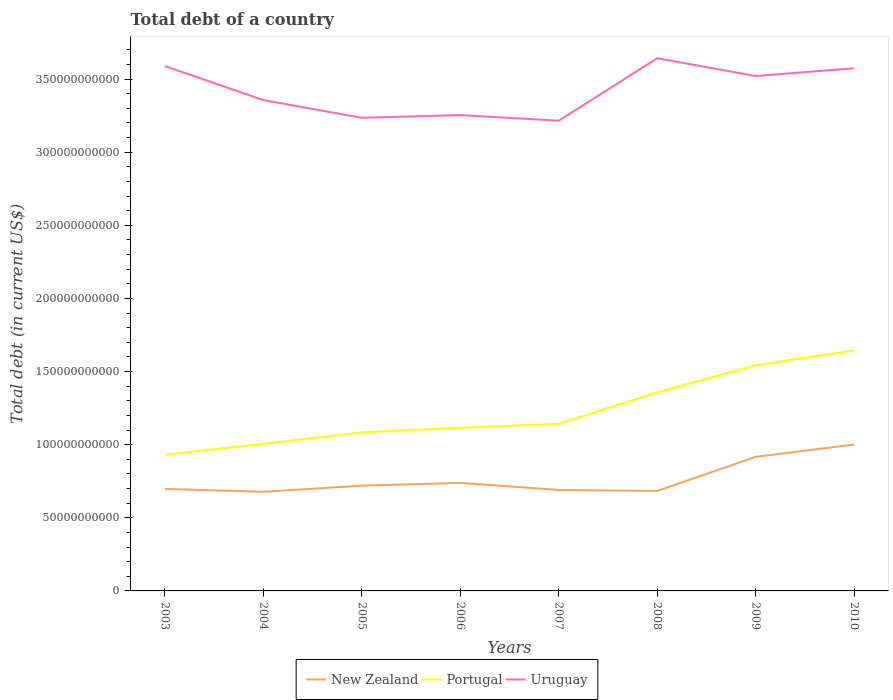How many different coloured lines are there?
Your answer should be compact. 3. Across all years, what is the maximum debt in Portugal?
Give a very brief answer. 9.32e+1. In which year was the debt in New Zealand maximum?
Your response must be concise. 2004. What is the total debt in Uruguay in the graph?
Offer a terse response. -1.85e+09. What is the difference between the highest and the second highest debt in New Zealand?
Your response must be concise. 3.23e+1. What is the difference between the highest and the lowest debt in New Zealand?
Keep it short and to the point. 2. Is the debt in New Zealand strictly greater than the debt in Portugal over the years?
Provide a succinct answer. Yes. How many lines are there?
Make the answer very short. 3. What is the difference between two consecutive major ticks on the Y-axis?
Ensure brevity in your answer.  5.00e+1. Does the graph contain any zero values?
Give a very brief answer. No. Where does the legend appear in the graph?
Your answer should be very brief. Bottom center. How many legend labels are there?
Ensure brevity in your answer.  3. How are the legend labels stacked?
Your answer should be compact. Horizontal. What is the title of the graph?
Offer a very short reply. Total debt of a country. Does "Uruguay" appear as one of the legend labels in the graph?
Offer a very short reply. Yes. What is the label or title of the Y-axis?
Give a very brief answer. Total debt (in current US$). What is the Total debt (in current US$) of New Zealand in 2003?
Offer a very short reply. 6.97e+1. What is the Total debt (in current US$) of Portugal in 2003?
Make the answer very short. 9.32e+1. What is the Total debt (in current US$) in Uruguay in 2003?
Your response must be concise. 3.59e+11. What is the Total debt (in current US$) in New Zealand in 2004?
Offer a very short reply. 6.78e+1. What is the Total debt (in current US$) in Portugal in 2004?
Your answer should be compact. 1.01e+11. What is the Total debt (in current US$) in Uruguay in 2004?
Provide a succinct answer. 3.36e+11. What is the Total debt (in current US$) of New Zealand in 2005?
Offer a terse response. 7.20e+1. What is the Total debt (in current US$) of Portugal in 2005?
Keep it short and to the point. 1.08e+11. What is the Total debt (in current US$) of Uruguay in 2005?
Give a very brief answer. 3.24e+11. What is the Total debt (in current US$) in New Zealand in 2006?
Offer a terse response. 7.39e+1. What is the Total debt (in current US$) in Portugal in 2006?
Keep it short and to the point. 1.12e+11. What is the Total debt (in current US$) of Uruguay in 2006?
Make the answer very short. 3.25e+11. What is the Total debt (in current US$) of New Zealand in 2007?
Make the answer very short. 6.90e+1. What is the Total debt (in current US$) of Portugal in 2007?
Provide a succinct answer. 1.14e+11. What is the Total debt (in current US$) in Uruguay in 2007?
Give a very brief answer. 3.22e+11. What is the Total debt (in current US$) of New Zealand in 2008?
Give a very brief answer. 6.84e+1. What is the Total debt (in current US$) in Portugal in 2008?
Make the answer very short. 1.36e+11. What is the Total debt (in current US$) of Uruguay in 2008?
Offer a terse response. 3.64e+11. What is the Total debt (in current US$) of New Zealand in 2009?
Your response must be concise. 9.17e+1. What is the Total debt (in current US$) in Portugal in 2009?
Offer a terse response. 1.54e+11. What is the Total debt (in current US$) in Uruguay in 2009?
Ensure brevity in your answer.  3.52e+11. What is the Total debt (in current US$) of New Zealand in 2010?
Offer a very short reply. 1.00e+11. What is the Total debt (in current US$) of Portugal in 2010?
Provide a succinct answer. 1.64e+11. What is the Total debt (in current US$) in Uruguay in 2010?
Your answer should be very brief. 3.57e+11. Across all years, what is the maximum Total debt (in current US$) in New Zealand?
Keep it short and to the point. 1.00e+11. Across all years, what is the maximum Total debt (in current US$) of Portugal?
Provide a succinct answer. 1.64e+11. Across all years, what is the maximum Total debt (in current US$) in Uruguay?
Your answer should be compact. 3.64e+11. Across all years, what is the minimum Total debt (in current US$) of New Zealand?
Keep it short and to the point. 6.78e+1. Across all years, what is the minimum Total debt (in current US$) in Portugal?
Offer a terse response. 9.32e+1. Across all years, what is the minimum Total debt (in current US$) of Uruguay?
Give a very brief answer. 3.22e+11. What is the total Total debt (in current US$) of New Zealand in the graph?
Ensure brevity in your answer.  6.13e+11. What is the total Total debt (in current US$) in Portugal in the graph?
Give a very brief answer. 9.83e+11. What is the total Total debt (in current US$) in Uruguay in the graph?
Your answer should be compact. 2.74e+12. What is the difference between the Total debt (in current US$) in New Zealand in 2003 and that in 2004?
Ensure brevity in your answer.  1.91e+09. What is the difference between the Total debt (in current US$) in Portugal in 2003 and that in 2004?
Make the answer very short. -7.46e+09. What is the difference between the Total debt (in current US$) in Uruguay in 2003 and that in 2004?
Offer a very short reply. 2.32e+1. What is the difference between the Total debt (in current US$) in New Zealand in 2003 and that in 2005?
Offer a terse response. -2.25e+09. What is the difference between the Total debt (in current US$) of Portugal in 2003 and that in 2005?
Give a very brief answer. -1.53e+1. What is the difference between the Total debt (in current US$) in Uruguay in 2003 and that in 2005?
Provide a succinct answer. 3.53e+1. What is the difference between the Total debt (in current US$) in New Zealand in 2003 and that in 2006?
Keep it short and to the point. -4.16e+09. What is the difference between the Total debt (in current US$) in Portugal in 2003 and that in 2006?
Your response must be concise. -1.84e+1. What is the difference between the Total debt (in current US$) of Uruguay in 2003 and that in 2006?
Your answer should be compact. 3.35e+1. What is the difference between the Total debt (in current US$) of New Zealand in 2003 and that in 2007?
Provide a short and direct response. 6.92e+08. What is the difference between the Total debt (in current US$) of Portugal in 2003 and that in 2007?
Offer a very short reply. -2.11e+1. What is the difference between the Total debt (in current US$) in Uruguay in 2003 and that in 2007?
Offer a very short reply. 3.73e+1. What is the difference between the Total debt (in current US$) in New Zealand in 2003 and that in 2008?
Make the answer very short. 1.35e+09. What is the difference between the Total debt (in current US$) of Portugal in 2003 and that in 2008?
Provide a succinct answer. -4.26e+1. What is the difference between the Total debt (in current US$) of Uruguay in 2003 and that in 2008?
Offer a terse response. -5.38e+09. What is the difference between the Total debt (in current US$) in New Zealand in 2003 and that in 2009?
Your answer should be very brief. -2.19e+1. What is the difference between the Total debt (in current US$) of Portugal in 2003 and that in 2009?
Offer a very short reply. -6.11e+1. What is the difference between the Total debt (in current US$) in Uruguay in 2003 and that in 2009?
Give a very brief answer. 6.76e+09. What is the difference between the Total debt (in current US$) of New Zealand in 2003 and that in 2010?
Give a very brief answer. -3.04e+1. What is the difference between the Total debt (in current US$) of Portugal in 2003 and that in 2010?
Your answer should be compact. -7.13e+1. What is the difference between the Total debt (in current US$) in Uruguay in 2003 and that in 2010?
Offer a terse response. 1.48e+09. What is the difference between the Total debt (in current US$) in New Zealand in 2004 and that in 2005?
Your response must be concise. -4.17e+09. What is the difference between the Total debt (in current US$) in Portugal in 2004 and that in 2005?
Make the answer very short. -7.86e+09. What is the difference between the Total debt (in current US$) of Uruguay in 2004 and that in 2005?
Give a very brief answer. 1.21e+1. What is the difference between the Total debt (in current US$) in New Zealand in 2004 and that in 2006?
Give a very brief answer. -6.08e+09. What is the difference between the Total debt (in current US$) of Portugal in 2004 and that in 2006?
Offer a terse response. -1.09e+1. What is the difference between the Total debt (in current US$) in Uruguay in 2004 and that in 2006?
Give a very brief answer. 1.02e+1. What is the difference between the Total debt (in current US$) of New Zealand in 2004 and that in 2007?
Your response must be concise. -1.22e+09. What is the difference between the Total debt (in current US$) of Portugal in 2004 and that in 2007?
Offer a very short reply. -1.37e+1. What is the difference between the Total debt (in current US$) of Uruguay in 2004 and that in 2007?
Offer a terse response. 1.41e+1. What is the difference between the Total debt (in current US$) of New Zealand in 2004 and that in 2008?
Make the answer very short. -5.67e+08. What is the difference between the Total debt (in current US$) in Portugal in 2004 and that in 2008?
Provide a short and direct response. -3.51e+1. What is the difference between the Total debt (in current US$) of Uruguay in 2004 and that in 2008?
Your answer should be very brief. -2.86e+1. What is the difference between the Total debt (in current US$) of New Zealand in 2004 and that in 2009?
Keep it short and to the point. -2.39e+1. What is the difference between the Total debt (in current US$) in Portugal in 2004 and that in 2009?
Ensure brevity in your answer.  -5.36e+1. What is the difference between the Total debt (in current US$) in Uruguay in 2004 and that in 2009?
Make the answer very short. -1.65e+1. What is the difference between the Total debt (in current US$) in New Zealand in 2004 and that in 2010?
Provide a short and direct response. -3.23e+1. What is the difference between the Total debt (in current US$) of Portugal in 2004 and that in 2010?
Keep it short and to the point. -6.39e+1. What is the difference between the Total debt (in current US$) of Uruguay in 2004 and that in 2010?
Provide a short and direct response. -2.18e+1. What is the difference between the Total debt (in current US$) in New Zealand in 2005 and that in 2006?
Ensure brevity in your answer.  -1.91e+09. What is the difference between the Total debt (in current US$) in Portugal in 2005 and that in 2006?
Provide a short and direct response. -3.09e+09. What is the difference between the Total debt (in current US$) of Uruguay in 2005 and that in 2006?
Provide a short and direct response. -1.85e+09. What is the difference between the Total debt (in current US$) in New Zealand in 2005 and that in 2007?
Offer a terse response. 2.95e+09. What is the difference between the Total debt (in current US$) of Portugal in 2005 and that in 2007?
Ensure brevity in your answer.  -5.83e+09. What is the difference between the Total debt (in current US$) of Uruguay in 2005 and that in 2007?
Make the answer very short. 1.99e+09. What is the difference between the Total debt (in current US$) of New Zealand in 2005 and that in 2008?
Offer a very short reply. 3.60e+09. What is the difference between the Total debt (in current US$) in Portugal in 2005 and that in 2008?
Keep it short and to the point. -2.73e+1. What is the difference between the Total debt (in current US$) in Uruguay in 2005 and that in 2008?
Your answer should be very brief. -4.07e+1. What is the difference between the Total debt (in current US$) in New Zealand in 2005 and that in 2009?
Make the answer very short. -1.97e+1. What is the difference between the Total debt (in current US$) in Portugal in 2005 and that in 2009?
Your answer should be very brief. -4.58e+1. What is the difference between the Total debt (in current US$) in Uruguay in 2005 and that in 2009?
Make the answer very short. -2.86e+1. What is the difference between the Total debt (in current US$) in New Zealand in 2005 and that in 2010?
Keep it short and to the point. -2.81e+1. What is the difference between the Total debt (in current US$) of Portugal in 2005 and that in 2010?
Ensure brevity in your answer.  -5.60e+1. What is the difference between the Total debt (in current US$) in Uruguay in 2005 and that in 2010?
Make the answer very short. -3.39e+1. What is the difference between the Total debt (in current US$) of New Zealand in 2006 and that in 2007?
Offer a very short reply. 4.86e+09. What is the difference between the Total debt (in current US$) in Portugal in 2006 and that in 2007?
Your answer should be very brief. -2.74e+09. What is the difference between the Total debt (in current US$) of Uruguay in 2006 and that in 2007?
Make the answer very short. 3.85e+09. What is the difference between the Total debt (in current US$) in New Zealand in 2006 and that in 2008?
Keep it short and to the point. 5.51e+09. What is the difference between the Total debt (in current US$) of Portugal in 2006 and that in 2008?
Your response must be concise. -2.42e+1. What is the difference between the Total debt (in current US$) in Uruguay in 2006 and that in 2008?
Give a very brief answer. -3.89e+1. What is the difference between the Total debt (in current US$) in New Zealand in 2006 and that in 2009?
Your answer should be very brief. -1.78e+1. What is the difference between the Total debt (in current US$) in Portugal in 2006 and that in 2009?
Keep it short and to the point. -4.27e+1. What is the difference between the Total debt (in current US$) in Uruguay in 2006 and that in 2009?
Give a very brief answer. -2.67e+1. What is the difference between the Total debt (in current US$) of New Zealand in 2006 and that in 2010?
Offer a very short reply. -2.62e+1. What is the difference between the Total debt (in current US$) of Portugal in 2006 and that in 2010?
Keep it short and to the point. -5.29e+1. What is the difference between the Total debt (in current US$) in Uruguay in 2006 and that in 2010?
Offer a terse response. -3.20e+1. What is the difference between the Total debt (in current US$) of New Zealand in 2007 and that in 2008?
Your answer should be compact. 6.55e+08. What is the difference between the Total debt (in current US$) of Portugal in 2007 and that in 2008?
Give a very brief answer. -2.15e+1. What is the difference between the Total debt (in current US$) of Uruguay in 2007 and that in 2008?
Provide a short and direct response. -4.27e+1. What is the difference between the Total debt (in current US$) in New Zealand in 2007 and that in 2009?
Offer a very short reply. -2.26e+1. What is the difference between the Total debt (in current US$) of Portugal in 2007 and that in 2009?
Provide a short and direct response. -4.00e+1. What is the difference between the Total debt (in current US$) of Uruguay in 2007 and that in 2009?
Keep it short and to the point. -3.06e+1. What is the difference between the Total debt (in current US$) in New Zealand in 2007 and that in 2010?
Provide a short and direct response. -3.11e+1. What is the difference between the Total debt (in current US$) of Portugal in 2007 and that in 2010?
Provide a short and direct response. -5.02e+1. What is the difference between the Total debt (in current US$) of Uruguay in 2007 and that in 2010?
Provide a succinct answer. -3.58e+1. What is the difference between the Total debt (in current US$) in New Zealand in 2008 and that in 2009?
Offer a very short reply. -2.33e+1. What is the difference between the Total debt (in current US$) in Portugal in 2008 and that in 2009?
Keep it short and to the point. -1.85e+1. What is the difference between the Total debt (in current US$) in Uruguay in 2008 and that in 2009?
Offer a very short reply. 1.21e+1. What is the difference between the Total debt (in current US$) of New Zealand in 2008 and that in 2010?
Make the answer very short. -3.17e+1. What is the difference between the Total debt (in current US$) in Portugal in 2008 and that in 2010?
Give a very brief answer. -2.87e+1. What is the difference between the Total debt (in current US$) in Uruguay in 2008 and that in 2010?
Ensure brevity in your answer.  6.86e+09. What is the difference between the Total debt (in current US$) of New Zealand in 2009 and that in 2010?
Make the answer very short. -8.43e+09. What is the difference between the Total debt (in current US$) of Portugal in 2009 and that in 2010?
Offer a terse response. -1.02e+1. What is the difference between the Total debt (in current US$) of Uruguay in 2009 and that in 2010?
Keep it short and to the point. -5.28e+09. What is the difference between the Total debt (in current US$) in New Zealand in 2003 and the Total debt (in current US$) in Portugal in 2004?
Your response must be concise. -3.09e+1. What is the difference between the Total debt (in current US$) of New Zealand in 2003 and the Total debt (in current US$) of Uruguay in 2004?
Keep it short and to the point. -2.66e+11. What is the difference between the Total debt (in current US$) of Portugal in 2003 and the Total debt (in current US$) of Uruguay in 2004?
Your answer should be compact. -2.42e+11. What is the difference between the Total debt (in current US$) of New Zealand in 2003 and the Total debt (in current US$) of Portugal in 2005?
Ensure brevity in your answer.  -3.88e+1. What is the difference between the Total debt (in current US$) of New Zealand in 2003 and the Total debt (in current US$) of Uruguay in 2005?
Give a very brief answer. -2.54e+11. What is the difference between the Total debt (in current US$) of Portugal in 2003 and the Total debt (in current US$) of Uruguay in 2005?
Make the answer very short. -2.30e+11. What is the difference between the Total debt (in current US$) of New Zealand in 2003 and the Total debt (in current US$) of Portugal in 2006?
Provide a succinct answer. -4.19e+1. What is the difference between the Total debt (in current US$) in New Zealand in 2003 and the Total debt (in current US$) in Uruguay in 2006?
Provide a short and direct response. -2.56e+11. What is the difference between the Total debt (in current US$) in Portugal in 2003 and the Total debt (in current US$) in Uruguay in 2006?
Your response must be concise. -2.32e+11. What is the difference between the Total debt (in current US$) of New Zealand in 2003 and the Total debt (in current US$) of Portugal in 2007?
Provide a short and direct response. -4.46e+1. What is the difference between the Total debt (in current US$) of New Zealand in 2003 and the Total debt (in current US$) of Uruguay in 2007?
Offer a very short reply. -2.52e+11. What is the difference between the Total debt (in current US$) of Portugal in 2003 and the Total debt (in current US$) of Uruguay in 2007?
Offer a very short reply. -2.28e+11. What is the difference between the Total debt (in current US$) of New Zealand in 2003 and the Total debt (in current US$) of Portugal in 2008?
Offer a very short reply. -6.61e+1. What is the difference between the Total debt (in current US$) in New Zealand in 2003 and the Total debt (in current US$) in Uruguay in 2008?
Provide a succinct answer. -2.94e+11. What is the difference between the Total debt (in current US$) in Portugal in 2003 and the Total debt (in current US$) in Uruguay in 2008?
Give a very brief answer. -2.71e+11. What is the difference between the Total debt (in current US$) of New Zealand in 2003 and the Total debt (in current US$) of Portugal in 2009?
Give a very brief answer. -8.46e+1. What is the difference between the Total debt (in current US$) in New Zealand in 2003 and the Total debt (in current US$) in Uruguay in 2009?
Provide a succinct answer. -2.82e+11. What is the difference between the Total debt (in current US$) in Portugal in 2003 and the Total debt (in current US$) in Uruguay in 2009?
Provide a succinct answer. -2.59e+11. What is the difference between the Total debt (in current US$) in New Zealand in 2003 and the Total debt (in current US$) in Portugal in 2010?
Give a very brief answer. -9.48e+1. What is the difference between the Total debt (in current US$) in New Zealand in 2003 and the Total debt (in current US$) in Uruguay in 2010?
Give a very brief answer. -2.88e+11. What is the difference between the Total debt (in current US$) in Portugal in 2003 and the Total debt (in current US$) in Uruguay in 2010?
Offer a terse response. -2.64e+11. What is the difference between the Total debt (in current US$) of New Zealand in 2004 and the Total debt (in current US$) of Portugal in 2005?
Keep it short and to the point. -4.07e+1. What is the difference between the Total debt (in current US$) in New Zealand in 2004 and the Total debt (in current US$) in Uruguay in 2005?
Give a very brief answer. -2.56e+11. What is the difference between the Total debt (in current US$) of Portugal in 2004 and the Total debt (in current US$) of Uruguay in 2005?
Offer a very short reply. -2.23e+11. What is the difference between the Total debt (in current US$) in New Zealand in 2004 and the Total debt (in current US$) in Portugal in 2006?
Ensure brevity in your answer.  -4.38e+1. What is the difference between the Total debt (in current US$) of New Zealand in 2004 and the Total debt (in current US$) of Uruguay in 2006?
Your response must be concise. -2.58e+11. What is the difference between the Total debt (in current US$) in Portugal in 2004 and the Total debt (in current US$) in Uruguay in 2006?
Offer a terse response. -2.25e+11. What is the difference between the Total debt (in current US$) of New Zealand in 2004 and the Total debt (in current US$) of Portugal in 2007?
Your answer should be compact. -4.65e+1. What is the difference between the Total debt (in current US$) in New Zealand in 2004 and the Total debt (in current US$) in Uruguay in 2007?
Make the answer very short. -2.54e+11. What is the difference between the Total debt (in current US$) of Portugal in 2004 and the Total debt (in current US$) of Uruguay in 2007?
Your response must be concise. -2.21e+11. What is the difference between the Total debt (in current US$) of New Zealand in 2004 and the Total debt (in current US$) of Portugal in 2008?
Provide a short and direct response. -6.80e+1. What is the difference between the Total debt (in current US$) in New Zealand in 2004 and the Total debt (in current US$) in Uruguay in 2008?
Your answer should be compact. -2.96e+11. What is the difference between the Total debt (in current US$) of Portugal in 2004 and the Total debt (in current US$) of Uruguay in 2008?
Offer a terse response. -2.64e+11. What is the difference between the Total debt (in current US$) of New Zealand in 2004 and the Total debt (in current US$) of Portugal in 2009?
Keep it short and to the point. -8.65e+1. What is the difference between the Total debt (in current US$) of New Zealand in 2004 and the Total debt (in current US$) of Uruguay in 2009?
Offer a very short reply. -2.84e+11. What is the difference between the Total debt (in current US$) in Portugal in 2004 and the Total debt (in current US$) in Uruguay in 2009?
Provide a short and direct response. -2.51e+11. What is the difference between the Total debt (in current US$) of New Zealand in 2004 and the Total debt (in current US$) of Portugal in 2010?
Offer a terse response. -9.67e+1. What is the difference between the Total debt (in current US$) of New Zealand in 2004 and the Total debt (in current US$) of Uruguay in 2010?
Give a very brief answer. -2.90e+11. What is the difference between the Total debt (in current US$) of Portugal in 2004 and the Total debt (in current US$) of Uruguay in 2010?
Provide a short and direct response. -2.57e+11. What is the difference between the Total debt (in current US$) in New Zealand in 2005 and the Total debt (in current US$) in Portugal in 2006?
Provide a short and direct response. -3.96e+1. What is the difference between the Total debt (in current US$) of New Zealand in 2005 and the Total debt (in current US$) of Uruguay in 2006?
Provide a short and direct response. -2.53e+11. What is the difference between the Total debt (in current US$) of Portugal in 2005 and the Total debt (in current US$) of Uruguay in 2006?
Offer a very short reply. -2.17e+11. What is the difference between the Total debt (in current US$) of New Zealand in 2005 and the Total debt (in current US$) of Portugal in 2007?
Keep it short and to the point. -4.23e+1. What is the difference between the Total debt (in current US$) of New Zealand in 2005 and the Total debt (in current US$) of Uruguay in 2007?
Your answer should be very brief. -2.50e+11. What is the difference between the Total debt (in current US$) in Portugal in 2005 and the Total debt (in current US$) in Uruguay in 2007?
Keep it short and to the point. -2.13e+11. What is the difference between the Total debt (in current US$) in New Zealand in 2005 and the Total debt (in current US$) in Portugal in 2008?
Your response must be concise. -6.38e+1. What is the difference between the Total debt (in current US$) of New Zealand in 2005 and the Total debt (in current US$) of Uruguay in 2008?
Offer a terse response. -2.92e+11. What is the difference between the Total debt (in current US$) in Portugal in 2005 and the Total debt (in current US$) in Uruguay in 2008?
Offer a very short reply. -2.56e+11. What is the difference between the Total debt (in current US$) in New Zealand in 2005 and the Total debt (in current US$) in Portugal in 2009?
Provide a succinct answer. -8.23e+1. What is the difference between the Total debt (in current US$) in New Zealand in 2005 and the Total debt (in current US$) in Uruguay in 2009?
Your answer should be very brief. -2.80e+11. What is the difference between the Total debt (in current US$) of Portugal in 2005 and the Total debt (in current US$) of Uruguay in 2009?
Provide a short and direct response. -2.44e+11. What is the difference between the Total debt (in current US$) in New Zealand in 2005 and the Total debt (in current US$) in Portugal in 2010?
Provide a succinct answer. -9.25e+1. What is the difference between the Total debt (in current US$) of New Zealand in 2005 and the Total debt (in current US$) of Uruguay in 2010?
Provide a short and direct response. -2.85e+11. What is the difference between the Total debt (in current US$) of Portugal in 2005 and the Total debt (in current US$) of Uruguay in 2010?
Give a very brief answer. -2.49e+11. What is the difference between the Total debt (in current US$) in New Zealand in 2006 and the Total debt (in current US$) in Portugal in 2007?
Your answer should be compact. -4.04e+1. What is the difference between the Total debt (in current US$) in New Zealand in 2006 and the Total debt (in current US$) in Uruguay in 2007?
Your response must be concise. -2.48e+11. What is the difference between the Total debt (in current US$) of Portugal in 2006 and the Total debt (in current US$) of Uruguay in 2007?
Give a very brief answer. -2.10e+11. What is the difference between the Total debt (in current US$) of New Zealand in 2006 and the Total debt (in current US$) of Portugal in 2008?
Provide a succinct answer. -6.19e+1. What is the difference between the Total debt (in current US$) of New Zealand in 2006 and the Total debt (in current US$) of Uruguay in 2008?
Your answer should be compact. -2.90e+11. What is the difference between the Total debt (in current US$) in Portugal in 2006 and the Total debt (in current US$) in Uruguay in 2008?
Your response must be concise. -2.53e+11. What is the difference between the Total debt (in current US$) of New Zealand in 2006 and the Total debt (in current US$) of Portugal in 2009?
Make the answer very short. -8.04e+1. What is the difference between the Total debt (in current US$) in New Zealand in 2006 and the Total debt (in current US$) in Uruguay in 2009?
Offer a very short reply. -2.78e+11. What is the difference between the Total debt (in current US$) of Portugal in 2006 and the Total debt (in current US$) of Uruguay in 2009?
Offer a very short reply. -2.41e+11. What is the difference between the Total debt (in current US$) of New Zealand in 2006 and the Total debt (in current US$) of Portugal in 2010?
Keep it short and to the point. -9.06e+1. What is the difference between the Total debt (in current US$) in New Zealand in 2006 and the Total debt (in current US$) in Uruguay in 2010?
Make the answer very short. -2.83e+11. What is the difference between the Total debt (in current US$) of Portugal in 2006 and the Total debt (in current US$) of Uruguay in 2010?
Your response must be concise. -2.46e+11. What is the difference between the Total debt (in current US$) of New Zealand in 2007 and the Total debt (in current US$) of Portugal in 2008?
Provide a succinct answer. -6.67e+1. What is the difference between the Total debt (in current US$) of New Zealand in 2007 and the Total debt (in current US$) of Uruguay in 2008?
Provide a succinct answer. -2.95e+11. What is the difference between the Total debt (in current US$) of Portugal in 2007 and the Total debt (in current US$) of Uruguay in 2008?
Your answer should be very brief. -2.50e+11. What is the difference between the Total debt (in current US$) in New Zealand in 2007 and the Total debt (in current US$) in Portugal in 2009?
Offer a very short reply. -8.52e+1. What is the difference between the Total debt (in current US$) of New Zealand in 2007 and the Total debt (in current US$) of Uruguay in 2009?
Offer a terse response. -2.83e+11. What is the difference between the Total debt (in current US$) in Portugal in 2007 and the Total debt (in current US$) in Uruguay in 2009?
Offer a terse response. -2.38e+11. What is the difference between the Total debt (in current US$) in New Zealand in 2007 and the Total debt (in current US$) in Portugal in 2010?
Keep it short and to the point. -9.55e+1. What is the difference between the Total debt (in current US$) in New Zealand in 2007 and the Total debt (in current US$) in Uruguay in 2010?
Your response must be concise. -2.88e+11. What is the difference between the Total debt (in current US$) of Portugal in 2007 and the Total debt (in current US$) of Uruguay in 2010?
Provide a succinct answer. -2.43e+11. What is the difference between the Total debt (in current US$) of New Zealand in 2008 and the Total debt (in current US$) of Portugal in 2009?
Your response must be concise. -8.59e+1. What is the difference between the Total debt (in current US$) in New Zealand in 2008 and the Total debt (in current US$) in Uruguay in 2009?
Provide a short and direct response. -2.84e+11. What is the difference between the Total debt (in current US$) of Portugal in 2008 and the Total debt (in current US$) of Uruguay in 2009?
Ensure brevity in your answer.  -2.16e+11. What is the difference between the Total debt (in current US$) of New Zealand in 2008 and the Total debt (in current US$) of Portugal in 2010?
Your answer should be compact. -9.61e+1. What is the difference between the Total debt (in current US$) in New Zealand in 2008 and the Total debt (in current US$) in Uruguay in 2010?
Provide a short and direct response. -2.89e+11. What is the difference between the Total debt (in current US$) of Portugal in 2008 and the Total debt (in current US$) of Uruguay in 2010?
Ensure brevity in your answer.  -2.22e+11. What is the difference between the Total debt (in current US$) in New Zealand in 2009 and the Total debt (in current US$) in Portugal in 2010?
Your response must be concise. -7.28e+1. What is the difference between the Total debt (in current US$) of New Zealand in 2009 and the Total debt (in current US$) of Uruguay in 2010?
Your response must be concise. -2.66e+11. What is the difference between the Total debt (in current US$) in Portugal in 2009 and the Total debt (in current US$) in Uruguay in 2010?
Your answer should be compact. -2.03e+11. What is the average Total debt (in current US$) of New Zealand per year?
Your answer should be compact. 7.66e+1. What is the average Total debt (in current US$) of Portugal per year?
Give a very brief answer. 1.23e+11. What is the average Total debt (in current US$) of Uruguay per year?
Ensure brevity in your answer.  3.42e+11. In the year 2003, what is the difference between the Total debt (in current US$) in New Zealand and Total debt (in current US$) in Portugal?
Your answer should be compact. -2.34e+1. In the year 2003, what is the difference between the Total debt (in current US$) of New Zealand and Total debt (in current US$) of Uruguay?
Your answer should be compact. -2.89e+11. In the year 2003, what is the difference between the Total debt (in current US$) in Portugal and Total debt (in current US$) in Uruguay?
Ensure brevity in your answer.  -2.66e+11. In the year 2004, what is the difference between the Total debt (in current US$) of New Zealand and Total debt (in current US$) of Portugal?
Offer a terse response. -3.28e+1. In the year 2004, what is the difference between the Total debt (in current US$) of New Zealand and Total debt (in current US$) of Uruguay?
Ensure brevity in your answer.  -2.68e+11. In the year 2004, what is the difference between the Total debt (in current US$) in Portugal and Total debt (in current US$) in Uruguay?
Ensure brevity in your answer.  -2.35e+11. In the year 2005, what is the difference between the Total debt (in current US$) in New Zealand and Total debt (in current US$) in Portugal?
Give a very brief answer. -3.65e+1. In the year 2005, what is the difference between the Total debt (in current US$) of New Zealand and Total debt (in current US$) of Uruguay?
Offer a terse response. -2.52e+11. In the year 2005, what is the difference between the Total debt (in current US$) of Portugal and Total debt (in current US$) of Uruguay?
Offer a very short reply. -2.15e+11. In the year 2006, what is the difference between the Total debt (in current US$) of New Zealand and Total debt (in current US$) of Portugal?
Make the answer very short. -3.77e+1. In the year 2006, what is the difference between the Total debt (in current US$) of New Zealand and Total debt (in current US$) of Uruguay?
Your answer should be very brief. -2.51e+11. In the year 2006, what is the difference between the Total debt (in current US$) in Portugal and Total debt (in current US$) in Uruguay?
Offer a terse response. -2.14e+11. In the year 2007, what is the difference between the Total debt (in current US$) in New Zealand and Total debt (in current US$) in Portugal?
Your response must be concise. -4.53e+1. In the year 2007, what is the difference between the Total debt (in current US$) of New Zealand and Total debt (in current US$) of Uruguay?
Keep it short and to the point. -2.52e+11. In the year 2007, what is the difference between the Total debt (in current US$) of Portugal and Total debt (in current US$) of Uruguay?
Your response must be concise. -2.07e+11. In the year 2008, what is the difference between the Total debt (in current US$) of New Zealand and Total debt (in current US$) of Portugal?
Your answer should be very brief. -6.74e+1. In the year 2008, what is the difference between the Total debt (in current US$) in New Zealand and Total debt (in current US$) in Uruguay?
Provide a short and direct response. -2.96e+11. In the year 2008, what is the difference between the Total debt (in current US$) of Portugal and Total debt (in current US$) of Uruguay?
Keep it short and to the point. -2.28e+11. In the year 2009, what is the difference between the Total debt (in current US$) in New Zealand and Total debt (in current US$) in Portugal?
Offer a terse response. -6.26e+1. In the year 2009, what is the difference between the Total debt (in current US$) in New Zealand and Total debt (in current US$) in Uruguay?
Offer a terse response. -2.60e+11. In the year 2009, what is the difference between the Total debt (in current US$) of Portugal and Total debt (in current US$) of Uruguay?
Provide a short and direct response. -1.98e+11. In the year 2010, what is the difference between the Total debt (in current US$) of New Zealand and Total debt (in current US$) of Portugal?
Give a very brief answer. -6.44e+1. In the year 2010, what is the difference between the Total debt (in current US$) in New Zealand and Total debt (in current US$) in Uruguay?
Offer a terse response. -2.57e+11. In the year 2010, what is the difference between the Total debt (in current US$) of Portugal and Total debt (in current US$) of Uruguay?
Provide a succinct answer. -1.93e+11. What is the ratio of the Total debt (in current US$) in New Zealand in 2003 to that in 2004?
Provide a short and direct response. 1.03. What is the ratio of the Total debt (in current US$) of Portugal in 2003 to that in 2004?
Offer a terse response. 0.93. What is the ratio of the Total debt (in current US$) of Uruguay in 2003 to that in 2004?
Make the answer very short. 1.07. What is the ratio of the Total debt (in current US$) in New Zealand in 2003 to that in 2005?
Offer a very short reply. 0.97. What is the ratio of the Total debt (in current US$) of Portugal in 2003 to that in 2005?
Give a very brief answer. 0.86. What is the ratio of the Total debt (in current US$) of Uruguay in 2003 to that in 2005?
Your response must be concise. 1.11. What is the ratio of the Total debt (in current US$) in New Zealand in 2003 to that in 2006?
Provide a succinct answer. 0.94. What is the ratio of the Total debt (in current US$) of Portugal in 2003 to that in 2006?
Your answer should be very brief. 0.83. What is the ratio of the Total debt (in current US$) of Uruguay in 2003 to that in 2006?
Offer a very short reply. 1.1. What is the ratio of the Total debt (in current US$) of Portugal in 2003 to that in 2007?
Your response must be concise. 0.81. What is the ratio of the Total debt (in current US$) of Uruguay in 2003 to that in 2007?
Ensure brevity in your answer.  1.12. What is the ratio of the Total debt (in current US$) of New Zealand in 2003 to that in 2008?
Provide a short and direct response. 1.02. What is the ratio of the Total debt (in current US$) in Portugal in 2003 to that in 2008?
Your answer should be very brief. 0.69. What is the ratio of the Total debt (in current US$) in Uruguay in 2003 to that in 2008?
Your answer should be very brief. 0.99. What is the ratio of the Total debt (in current US$) in New Zealand in 2003 to that in 2009?
Keep it short and to the point. 0.76. What is the ratio of the Total debt (in current US$) in Portugal in 2003 to that in 2009?
Ensure brevity in your answer.  0.6. What is the ratio of the Total debt (in current US$) in Uruguay in 2003 to that in 2009?
Your answer should be compact. 1.02. What is the ratio of the Total debt (in current US$) of New Zealand in 2003 to that in 2010?
Ensure brevity in your answer.  0.7. What is the ratio of the Total debt (in current US$) in Portugal in 2003 to that in 2010?
Offer a very short reply. 0.57. What is the ratio of the Total debt (in current US$) of Uruguay in 2003 to that in 2010?
Give a very brief answer. 1. What is the ratio of the Total debt (in current US$) of New Zealand in 2004 to that in 2005?
Give a very brief answer. 0.94. What is the ratio of the Total debt (in current US$) in Portugal in 2004 to that in 2005?
Keep it short and to the point. 0.93. What is the ratio of the Total debt (in current US$) in Uruguay in 2004 to that in 2005?
Provide a short and direct response. 1.04. What is the ratio of the Total debt (in current US$) of New Zealand in 2004 to that in 2006?
Provide a succinct answer. 0.92. What is the ratio of the Total debt (in current US$) in Portugal in 2004 to that in 2006?
Keep it short and to the point. 0.9. What is the ratio of the Total debt (in current US$) of Uruguay in 2004 to that in 2006?
Give a very brief answer. 1.03. What is the ratio of the Total debt (in current US$) of New Zealand in 2004 to that in 2007?
Give a very brief answer. 0.98. What is the ratio of the Total debt (in current US$) in Portugal in 2004 to that in 2007?
Give a very brief answer. 0.88. What is the ratio of the Total debt (in current US$) of Uruguay in 2004 to that in 2007?
Keep it short and to the point. 1.04. What is the ratio of the Total debt (in current US$) of New Zealand in 2004 to that in 2008?
Keep it short and to the point. 0.99. What is the ratio of the Total debt (in current US$) in Portugal in 2004 to that in 2008?
Your answer should be very brief. 0.74. What is the ratio of the Total debt (in current US$) of Uruguay in 2004 to that in 2008?
Offer a very short reply. 0.92. What is the ratio of the Total debt (in current US$) of New Zealand in 2004 to that in 2009?
Offer a very short reply. 0.74. What is the ratio of the Total debt (in current US$) of Portugal in 2004 to that in 2009?
Provide a short and direct response. 0.65. What is the ratio of the Total debt (in current US$) in Uruguay in 2004 to that in 2009?
Provide a succinct answer. 0.95. What is the ratio of the Total debt (in current US$) in New Zealand in 2004 to that in 2010?
Your response must be concise. 0.68. What is the ratio of the Total debt (in current US$) of Portugal in 2004 to that in 2010?
Give a very brief answer. 0.61. What is the ratio of the Total debt (in current US$) of Uruguay in 2004 to that in 2010?
Make the answer very short. 0.94. What is the ratio of the Total debt (in current US$) of New Zealand in 2005 to that in 2006?
Keep it short and to the point. 0.97. What is the ratio of the Total debt (in current US$) in Portugal in 2005 to that in 2006?
Provide a short and direct response. 0.97. What is the ratio of the Total debt (in current US$) in Uruguay in 2005 to that in 2006?
Offer a terse response. 0.99. What is the ratio of the Total debt (in current US$) of New Zealand in 2005 to that in 2007?
Keep it short and to the point. 1.04. What is the ratio of the Total debt (in current US$) in Portugal in 2005 to that in 2007?
Provide a succinct answer. 0.95. What is the ratio of the Total debt (in current US$) in New Zealand in 2005 to that in 2008?
Provide a short and direct response. 1.05. What is the ratio of the Total debt (in current US$) of Portugal in 2005 to that in 2008?
Ensure brevity in your answer.  0.8. What is the ratio of the Total debt (in current US$) in Uruguay in 2005 to that in 2008?
Offer a very short reply. 0.89. What is the ratio of the Total debt (in current US$) of New Zealand in 2005 to that in 2009?
Provide a short and direct response. 0.79. What is the ratio of the Total debt (in current US$) in Portugal in 2005 to that in 2009?
Provide a short and direct response. 0.7. What is the ratio of the Total debt (in current US$) of Uruguay in 2005 to that in 2009?
Your answer should be very brief. 0.92. What is the ratio of the Total debt (in current US$) of New Zealand in 2005 to that in 2010?
Make the answer very short. 0.72. What is the ratio of the Total debt (in current US$) of Portugal in 2005 to that in 2010?
Your answer should be very brief. 0.66. What is the ratio of the Total debt (in current US$) in Uruguay in 2005 to that in 2010?
Keep it short and to the point. 0.91. What is the ratio of the Total debt (in current US$) of New Zealand in 2006 to that in 2007?
Your answer should be very brief. 1.07. What is the ratio of the Total debt (in current US$) of Uruguay in 2006 to that in 2007?
Offer a terse response. 1.01. What is the ratio of the Total debt (in current US$) in New Zealand in 2006 to that in 2008?
Ensure brevity in your answer.  1.08. What is the ratio of the Total debt (in current US$) in Portugal in 2006 to that in 2008?
Make the answer very short. 0.82. What is the ratio of the Total debt (in current US$) of Uruguay in 2006 to that in 2008?
Ensure brevity in your answer.  0.89. What is the ratio of the Total debt (in current US$) in New Zealand in 2006 to that in 2009?
Ensure brevity in your answer.  0.81. What is the ratio of the Total debt (in current US$) of Portugal in 2006 to that in 2009?
Provide a succinct answer. 0.72. What is the ratio of the Total debt (in current US$) in Uruguay in 2006 to that in 2009?
Offer a terse response. 0.92. What is the ratio of the Total debt (in current US$) of New Zealand in 2006 to that in 2010?
Offer a very short reply. 0.74. What is the ratio of the Total debt (in current US$) of Portugal in 2006 to that in 2010?
Ensure brevity in your answer.  0.68. What is the ratio of the Total debt (in current US$) in Uruguay in 2006 to that in 2010?
Your response must be concise. 0.91. What is the ratio of the Total debt (in current US$) in New Zealand in 2007 to that in 2008?
Make the answer very short. 1.01. What is the ratio of the Total debt (in current US$) in Portugal in 2007 to that in 2008?
Your answer should be compact. 0.84. What is the ratio of the Total debt (in current US$) of Uruguay in 2007 to that in 2008?
Offer a terse response. 0.88. What is the ratio of the Total debt (in current US$) in New Zealand in 2007 to that in 2009?
Offer a terse response. 0.75. What is the ratio of the Total debt (in current US$) of Portugal in 2007 to that in 2009?
Keep it short and to the point. 0.74. What is the ratio of the Total debt (in current US$) in Uruguay in 2007 to that in 2009?
Make the answer very short. 0.91. What is the ratio of the Total debt (in current US$) of New Zealand in 2007 to that in 2010?
Offer a terse response. 0.69. What is the ratio of the Total debt (in current US$) of Portugal in 2007 to that in 2010?
Offer a terse response. 0.69. What is the ratio of the Total debt (in current US$) of Uruguay in 2007 to that in 2010?
Ensure brevity in your answer.  0.9. What is the ratio of the Total debt (in current US$) in New Zealand in 2008 to that in 2009?
Your response must be concise. 0.75. What is the ratio of the Total debt (in current US$) in Portugal in 2008 to that in 2009?
Your response must be concise. 0.88. What is the ratio of the Total debt (in current US$) in Uruguay in 2008 to that in 2009?
Give a very brief answer. 1.03. What is the ratio of the Total debt (in current US$) in New Zealand in 2008 to that in 2010?
Give a very brief answer. 0.68. What is the ratio of the Total debt (in current US$) in Portugal in 2008 to that in 2010?
Ensure brevity in your answer.  0.83. What is the ratio of the Total debt (in current US$) of Uruguay in 2008 to that in 2010?
Your answer should be compact. 1.02. What is the ratio of the Total debt (in current US$) in New Zealand in 2009 to that in 2010?
Your response must be concise. 0.92. What is the ratio of the Total debt (in current US$) of Portugal in 2009 to that in 2010?
Offer a terse response. 0.94. What is the ratio of the Total debt (in current US$) of Uruguay in 2009 to that in 2010?
Your answer should be very brief. 0.99. What is the difference between the highest and the second highest Total debt (in current US$) in New Zealand?
Offer a very short reply. 8.43e+09. What is the difference between the highest and the second highest Total debt (in current US$) in Portugal?
Make the answer very short. 1.02e+1. What is the difference between the highest and the second highest Total debt (in current US$) in Uruguay?
Keep it short and to the point. 5.38e+09. What is the difference between the highest and the lowest Total debt (in current US$) in New Zealand?
Offer a very short reply. 3.23e+1. What is the difference between the highest and the lowest Total debt (in current US$) in Portugal?
Provide a succinct answer. 7.13e+1. What is the difference between the highest and the lowest Total debt (in current US$) in Uruguay?
Your answer should be compact. 4.27e+1. 